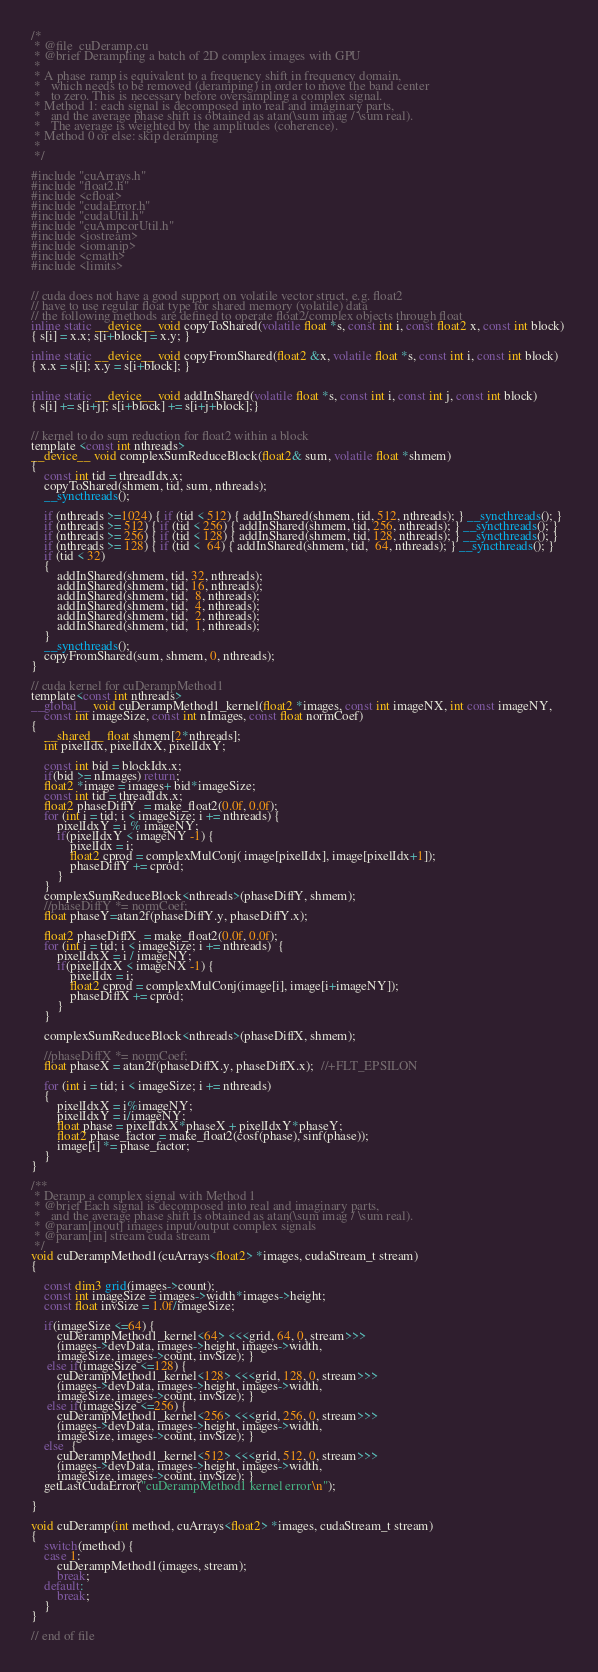<code> <loc_0><loc_0><loc_500><loc_500><_Cuda_>/*
 * @file  cuDeramp.cu
 * @brief Derampling a batch of 2D complex images with GPU
 *
 * A phase ramp is equivalent to a frequency shift in frequency domain,
 *   which needs to be removed (deramping) in order to move the band center
 *   to zero. This is necessary before oversampling a complex signal.
 * Method 1: each signal is decomposed into real and imaginary parts,
 *   and the average phase shift is obtained as atan(\sum imag / \sum real).
 *   The average is weighted by the amplitudes (coherence).
 * Method 0 or else: skip deramping
 *
 */
 
#include "cuArrays.h" 
#include "float2.h" 
#include <cfloat>
#include "cudaError.h"
#include "cudaUtil.h"
#include "cuAmpcorUtil.h"
#include <iostream>
#include <iomanip>
#include <cmath>
#include <limits>


// cuda does not have a good support on volatile vector struct, e.g. float2
// have to use regular float type for shared memory (volatile) data
// the following methods are defined to operate float2/complex objects through float
inline static __device__ void copyToShared(volatile float *s, const int i, const float2 x, const int block) 
{ s[i] = x.x; s[i+block] = x.y; }

inline static __device__ void copyFromShared(float2 &x, volatile float *s, const int i, const int block) 
{ x.x = s[i]; x.y = s[i+block]; }


inline static __device__ void addInShared(volatile float *s, const int i, const int j, const int block) 
{ s[i] += s[i+j]; s[i+block] += s[i+j+block];}


// kernel to do sum reduction for float2 within a block
template <const int nthreads>
__device__ void complexSumReduceBlock(float2& sum, volatile float *shmem)
{
    const int tid = threadIdx.x;
    copyToShared(shmem, tid, sum, nthreads);
    __syncthreads();
    
    if (nthreads >=1024) { if (tid < 512) { addInShared(shmem, tid, 512, nthreads); } __syncthreads(); }
    if (nthreads >= 512) { if (tid < 256) { addInShared(shmem, tid, 256, nthreads); } __syncthreads(); }
    if (nthreads >= 256) { if (tid < 128) { addInShared(shmem, tid, 128, nthreads); } __syncthreads(); }
    if (nthreads >= 128) { if (tid <  64) { addInShared(shmem, tid,  64, nthreads); } __syncthreads(); }
    if (tid < 32)
    {	
        addInShared(shmem, tid, 32, nthreads);
        addInShared(shmem, tid, 16, nthreads);
        addInShared(shmem, tid,  8, nthreads);
        addInShared(shmem, tid,  4, nthreads);
        addInShared(shmem, tid,  2, nthreads);
        addInShared(shmem, tid,  1, nthreads); 
    }
    __syncthreads();
    copyFromShared(sum, shmem, 0, nthreads);
}

// cuda kernel for cuDerampMethod1
template<const int nthreads>
__global__ void cuDerampMethod1_kernel(float2 *images, const int imageNX, int const imageNY, 
    const int imageSize, const int nImages, const float normCoef)
{
    __shared__ float shmem[2*nthreads];
    int pixelIdx, pixelIdxX, pixelIdxY;
    
    const int bid = blockIdx.x;    
    if(bid >= nImages) return;
    float2 *image = images+ bid*imageSize;
    const int tid = threadIdx.x;  
    float2 phaseDiffY  = make_float2(0.0f, 0.0f);
    for (int i = tid; i < imageSize; i += nthreads) {
        pixelIdxY = i % imageNY;
        if(pixelIdxY < imageNY -1) {
            pixelIdx = i;
            float2 cprod = complexMulConj( image[pixelIdx], image[pixelIdx+1]);   
            phaseDiffY += cprod;
        } 
    }       
    complexSumReduceBlock<nthreads>(phaseDiffY, shmem);
    //phaseDiffY *= normCoef;
    float phaseY=atan2f(phaseDiffY.y, phaseDiffY.x);

    float2 phaseDiffX  = make_float2(0.0f, 0.0f);
    for (int i = tid; i < imageSize; i += nthreads)  {
        pixelIdxX = i / imageNY; 
        if(pixelIdxX < imageNX -1) {
            pixelIdx = i;
            float2 cprod = complexMulConj(image[i], image[i+imageNY]);
            phaseDiffX += cprod;
        }
    }   
    
    complexSumReduceBlock<nthreads>(phaseDiffX, shmem);
   
    //phaseDiffX *= normCoef;
    float phaseX = atan2f(phaseDiffX.y, phaseDiffX.x);  //+FLT_EPSILON
     
    for (int i = tid; i < imageSize; i += nthreads)
    { 
        pixelIdxX = i%imageNY;
        pixelIdxY = i/imageNY;
        float phase = pixelIdxX*phaseX + pixelIdxY*phaseY;
        float2 phase_factor = make_float2(cosf(phase), sinf(phase));
        image[i] *= phase_factor;
    }     
}

/**
 * Deramp a complex signal with Method 1
 * @brief Each signal is decomposed into real and imaginary parts,
 *   and the average phase shift is obtained as atan(\sum imag / \sum real).
 * @param[inout] images input/output complex signals
 * @param[in] stream cuda stream
 */
void cuDerampMethod1(cuArrays<float2> *images, cudaStream_t stream)
{
    
    const dim3 grid(images->count);
    const int imageSize = images->width*images->height;
    const float invSize = 1.0f/imageSize;

    if(imageSize <=64) {
        cuDerampMethod1_kernel<64> <<<grid, 64, 0, stream>>>
        (images->devData, images->height, images->width, 
        imageSize, images->count, invSize); }
     else if(imageSize <=128) {
        cuDerampMethod1_kernel<128> <<<grid, 128, 0, stream>>>
        (images->devData, images->height, images->width, 
        imageSize, images->count, invSize); }   
     else if(imageSize <=256) {
        cuDerampMethod1_kernel<256> <<<grid, 256, 0, stream>>>
        (images->devData, images->height, images->width, 
        imageSize, images->count, invSize); }  
    else  {
        cuDerampMethod1_kernel<512> <<<grid, 512, 0, stream>>>
        (images->devData, images->height, images->width, 
        imageSize, images->count, invSize); }
    getLastCudaError("cuDerampMethod1 kernel error\n");

}
        
void cuDeramp(int method, cuArrays<float2> *images, cudaStream_t stream)
{
    switch(method) {
    case 1:
        cuDerampMethod1(images, stream);
        break;
    default:
        break;
    }
}

// end of file</code> 